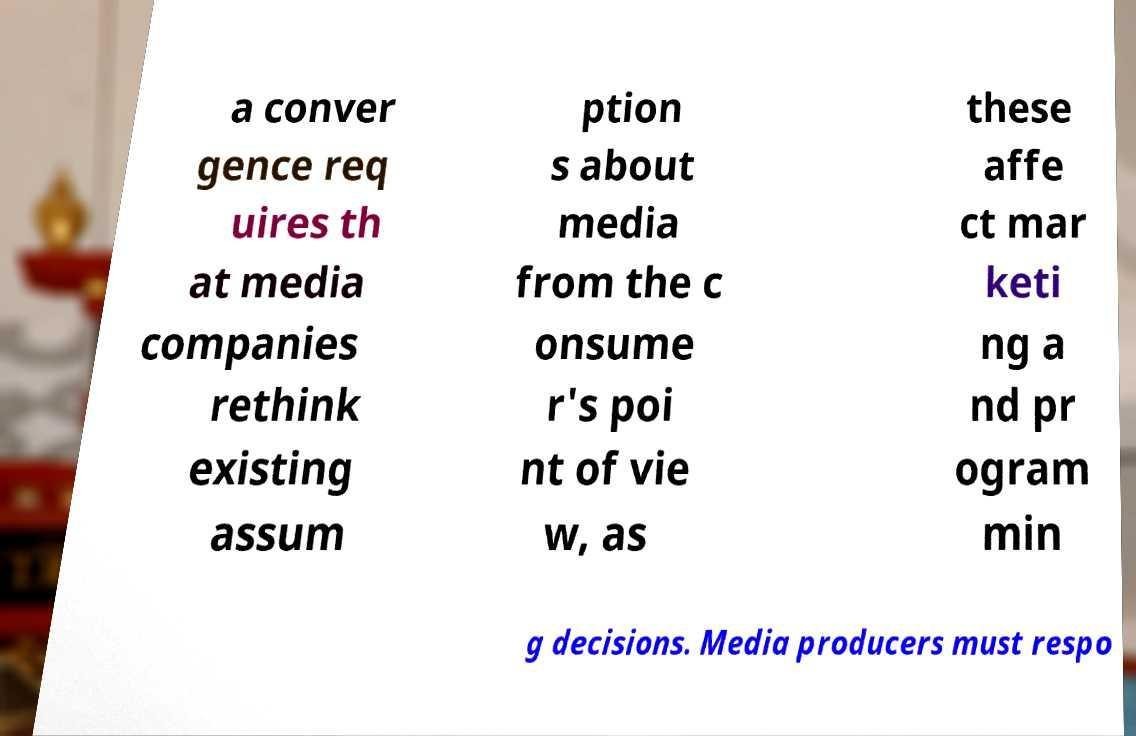There's text embedded in this image that I need extracted. Can you transcribe it verbatim? a conver gence req uires th at media companies rethink existing assum ption s about media from the c onsume r's poi nt of vie w, as these affe ct mar keti ng a nd pr ogram min g decisions. Media producers must respo 